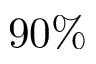Convert formula to latex. <formula><loc_0><loc_0><loc_500><loc_500>9 0 \%</formula> 